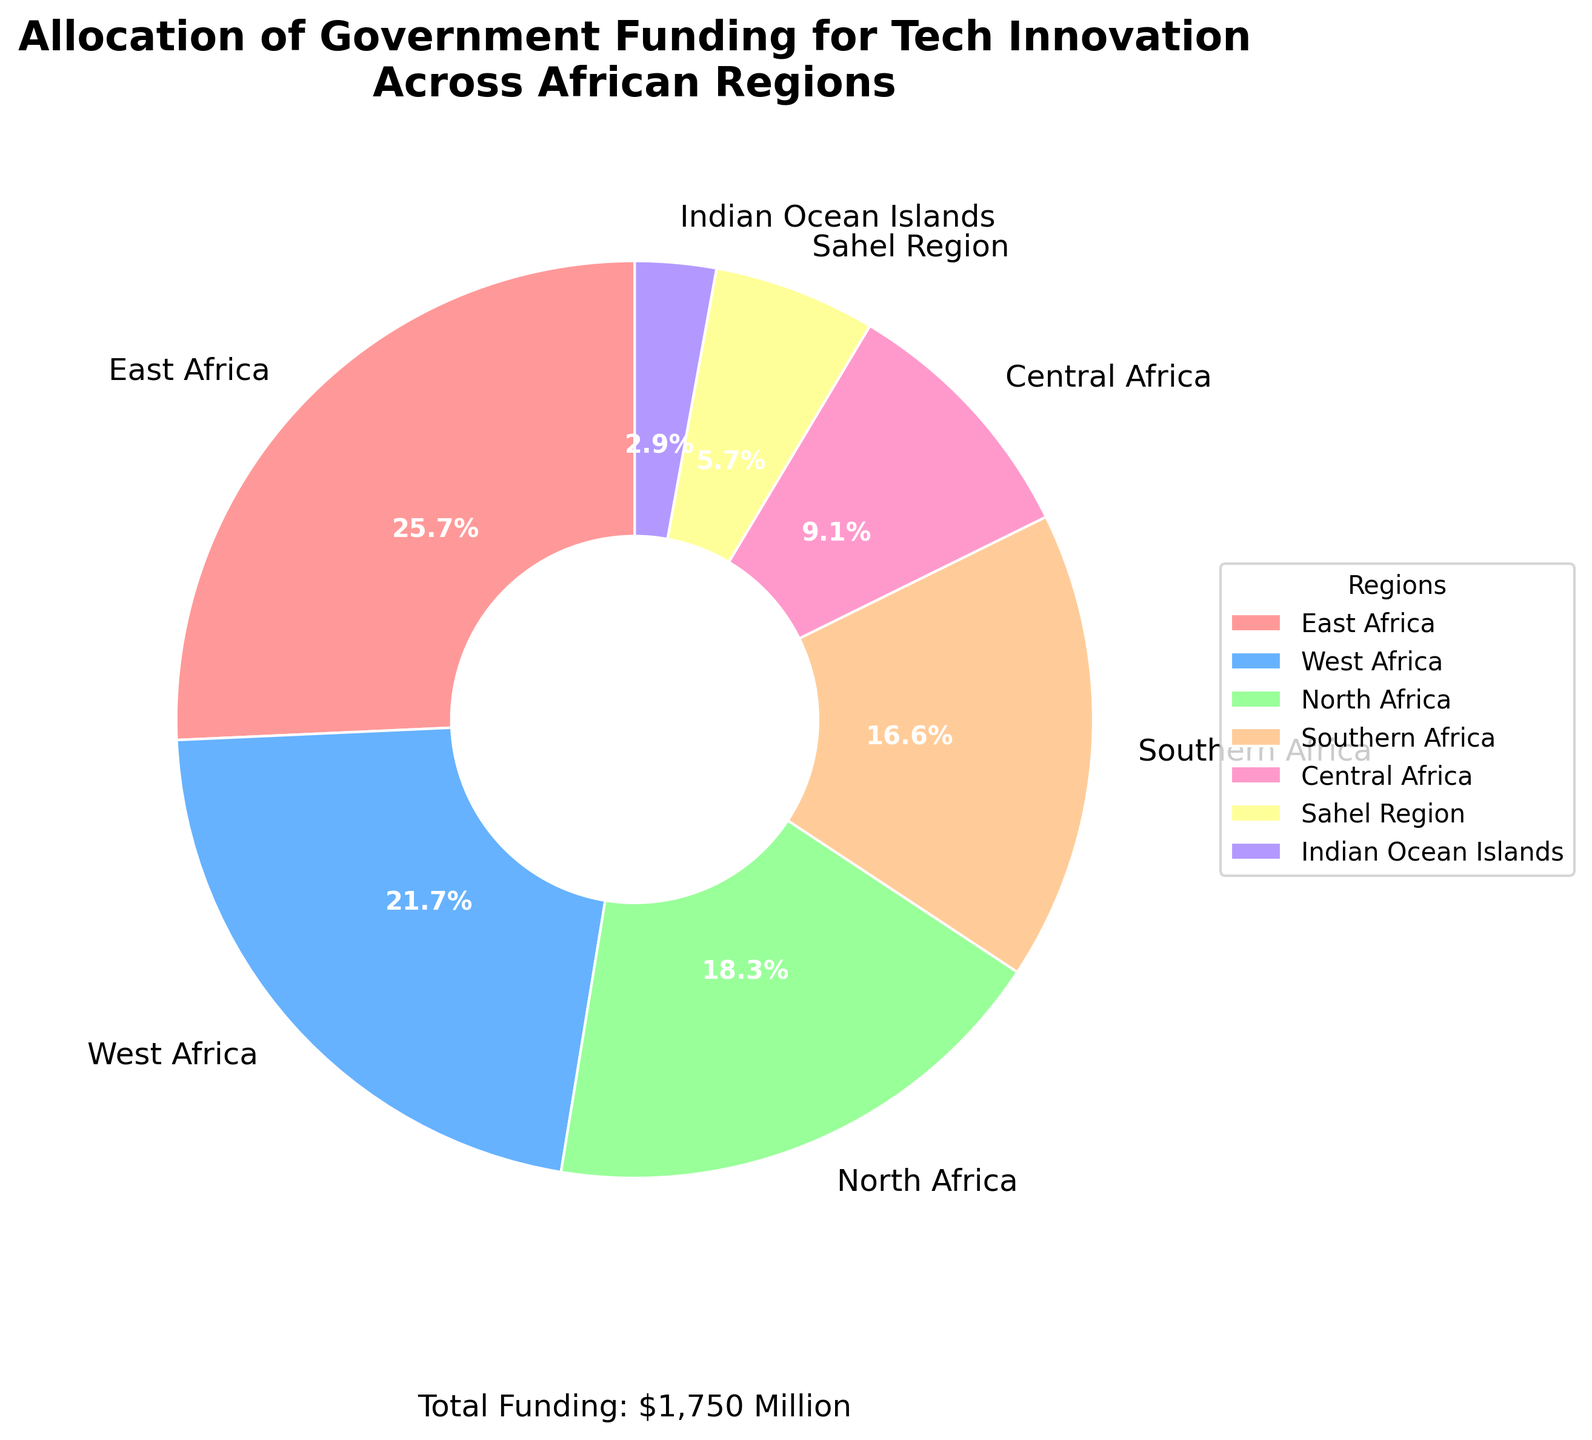What percentage of the total funding is allocated to East Africa? First, locate East Africa on the pie chart. The pie chart indicates that East Africa receives 450 million USD. The total funding is 1,750 million USD. Calculate the percentage by (450 / 1,750) * 100%.
Answer: 25.7% Which region receives the smallest allocation of government funding for tech innovation? Identify the region with the smallest segment in the pie chart. The smallest segment corresponds to the Indian Ocean Islands with 50 million USD.
Answer: Indian Ocean Islands How does the funding for West Africa compare to that for Central Africa? Compare the segments for West Africa and Central Africa on the pie chart. West Africa receives 380 million USD, and Central Africa receives 160 million USD.
Answer: West Africa receives more funding If Southern Africa's funding increased by 20%, what would be the new total funding and Southern Africa's percentage allocation? Southern Africa's current funding is 290 million USD. An increase of 20% means additional funding of (290 * 0.2) = 58 million USD. The new funding is 290 + 58 = 348 million USD. The new total funding is 1,750 + 58 = 1,808 million USD. The new percentage is (348 / 1,808) * 100%.
Answer: 19.2% Which two regions together receive over 50% of the total funding? Calculate the percentages for each region and identify combinations that exceed 50%. East Africa (25.7%) and West Africa (21.7%) together receive (25.7 + 21.7) = 47.4%. Including North Africa (18.3%) with any of the top two regions covers more than 50%.
Answer: East Africa and West Africa What is the combined funding allocation for the Sahel Region and Indian Ocean Islands? Identify the segments for the Sahel Region and Indian Ocean Islands on the chart. The Sahel Region receives 100 million USD and Indian Ocean Islands receive 50 million USD. Add these values: 100 + 50 = 150 million USD.
Answer: 150 million USD How much more funding does East Africa receive compared to the Sahel Region? Identify the funding for East Africa (450 million USD) and the Sahel Region (100 million USD). Subtract the two values: 450 - 100 = 350 million USD.
Answer: 350 million USD Which regions have a funding allocation difference of less than 100 million USD? Compare the funding allocations listed: North Africa (320 million USD), Southern Africa (290 million USD), West Africa (380 million USD), Central Africa (160 million USD). Compare pairs to find differences less than 100 million USD. North Africa and Southern Africa: 320 - 290 = 30 million USD. Southern Africa and Central Africa: 290 - 160 = 130 million USD (doesn't qualify).
Answer: North Africa and Southern Africa 